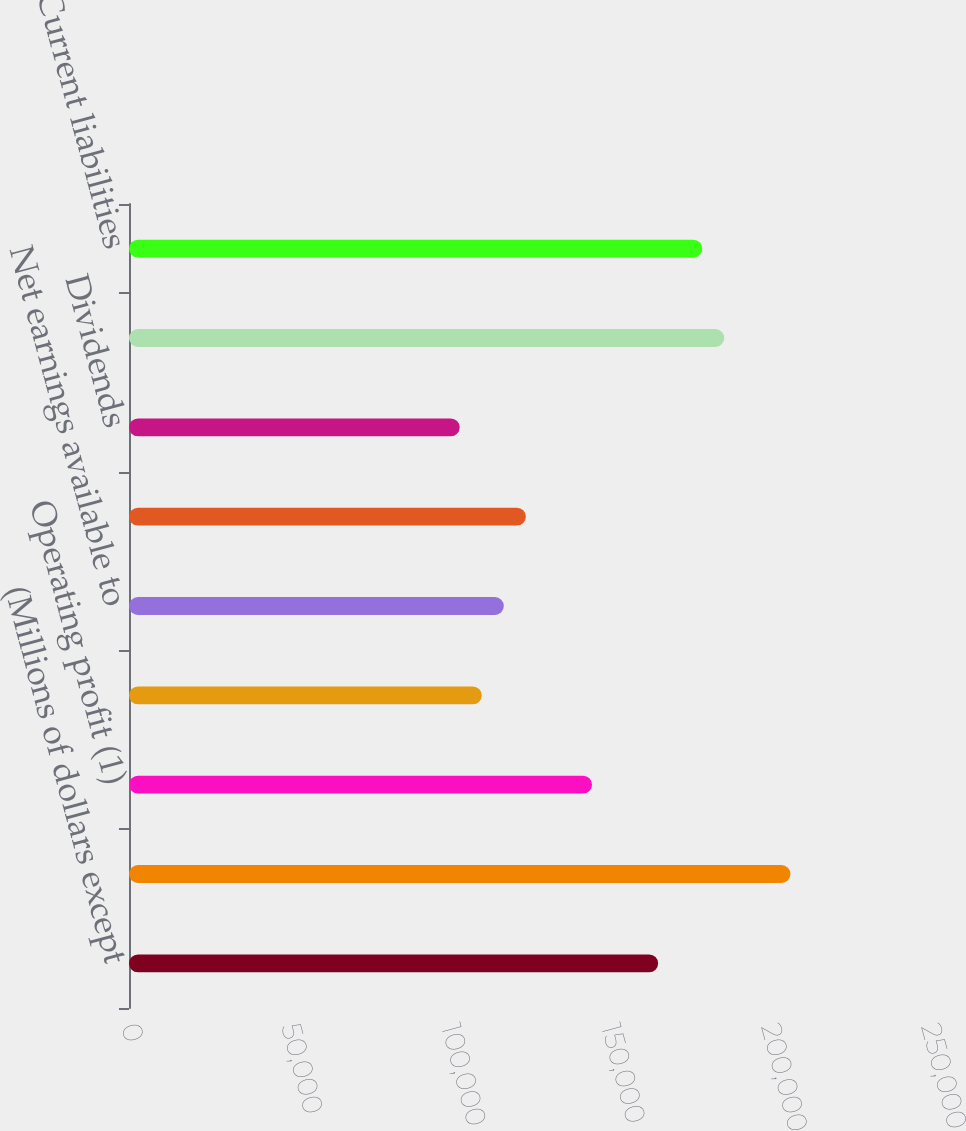Convert chart to OTSL. <chart><loc_0><loc_0><loc_500><loc_500><bar_chart><fcel>(Millions of dollars except<fcel>Net sales<fcel>Operating profit (1)<fcel>Earnings from continuing<fcel>Net earnings available to<fcel>Net capital expenditures<fcel>Dividends<fcel>Current assets<fcel>Current liabilities<nl><fcel>165363<fcel>206704<fcel>144693<fcel>110243<fcel>117133<fcel>124023<fcel>103352<fcel>186034<fcel>179143<nl></chart> 